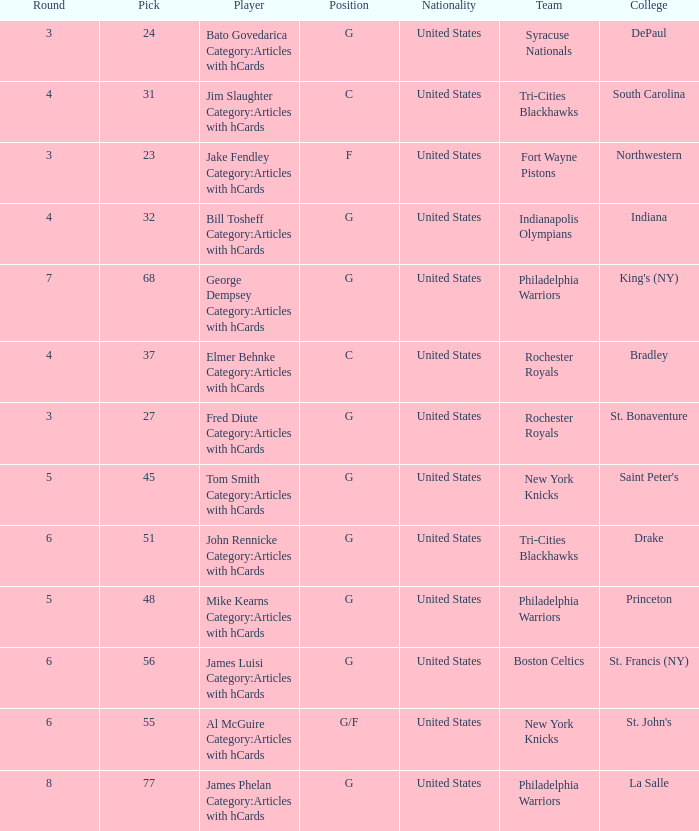What is the sum total of picks for drake players from the tri-cities blackhawks? 51.0. 